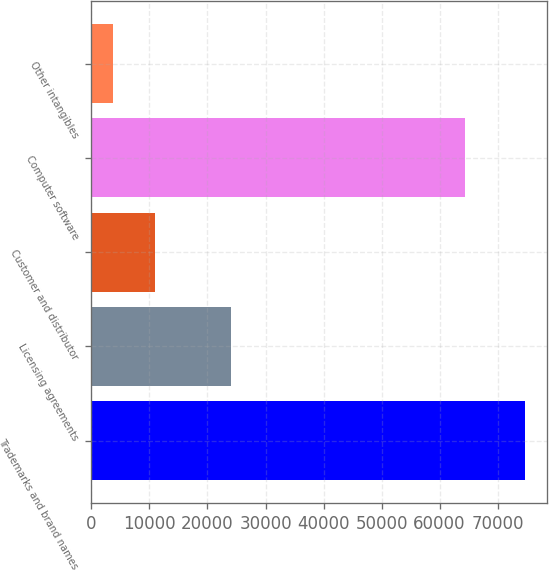Convert chart. <chart><loc_0><loc_0><loc_500><loc_500><bar_chart><fcel>Trademarks and brand names<fcel>Licensing agreements<fcel>Customer and distributor<fcel>Computer software<fcel>Other intangibles<nl><fcel>74810<fcel>24104<fcel>10883.9<fcel>64418<fcel>3781<nl></chart> 